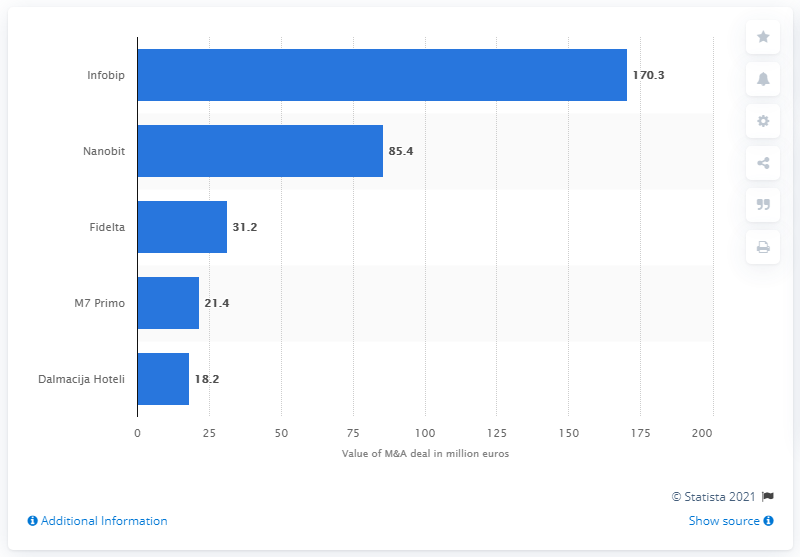Point out several critical features in this image. According to the records, Laguna Novigrad paid 18,200... for Dalmacija Hoteli. One Equity Partners paid $170.3 million for Infobip. 